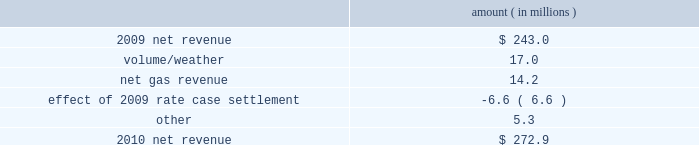Entergy new orleans , inc .
Management 2019s financial discussion and analysis the volume/weather variance is primarily due to an increase in electricity usage in the residential and commercial sectors due in part to a 4% ( 4 % ) increase in the average number of residential customers and a 3% ( 3 % ) increase in the average number of commercial customers , partially offset by the effect of less favorable weather on residential sales .
Gross operating revenues gross operating revenues decreased primarily due to : a decrease of $ 16.2 million in electric fuel cost recovery revenues due to lower fuel rates ; a decrease of $ 15.4 million in gross gas revenues primarily due to lower fuel cost recovery revenues as a result of lower fuel rates and the effect of milder weather ; and formula rate plan decreases effective october 2010 and october 2011 , as discussed above .
The decrease was partially offset by an increase in gross wholesale revenue due to increased sales to affiliated customers and more favorable volume/weather , as discussed above .
2010 compared to 2009 net revenue consists of operating revenues net of : 1 ) fuel , fuel-related expenses , and gas purchased for resale , 2 ) purchased power expenses , and 3 ) other regulatory charges ( credits ) .
Following is an analysis of the change in net revenue comparing 2010 to 2009 .
Amount ( in millions ) .
The volume/weather variance is primarily due to an increase of 348 gwh , or 7% ( 7 % ) , in billed retail electricity usage primarily due to more favorable weather compared to last year .
The net gas revenue variance is primarily due to more favorable weather compared to last year , along with the recognition of a gas regulatory asset associated with the settlement of entergy new orleans 2019s electric and gas formula rate plans .
See note 2 to the financial statements for further discussion of the formula rate plan settlement .
The effect of 2009 rate case settlement variance results from the april 2009 settlement of entergy new orleans 2019s rate case , and includes the effects of realigning non-fuel costs associated with the operation of grand gulf from the fuel adjustment clause to electric base rates effective june 2009 .
See note 2 to the financial statements for further discussion of the rate case settlement .
Other income statement variances 2011 compared to 2010 other operation and maintenance expenses decreased primarily due to the deferral in 2011 of $ 13.4 million of 2010 michoud plant maintenance costs pursuant to the settlement of entergy new orleans 2019s 2010 test year formula rate plan filing approved by the city council in september 2011 and a decrease of $ 8.0 million in fossil- fueled generation expenses due to higher plant outage costs in 2010 due to a greater scope of work at the michoud plant .
See note 2 to the financial statements for more discussion of the 2010 test year formula rate plan filing. .
What is the growth rate in net revenue from 2009 to 2010? 
Computations: ((272.9 - 243.0) / 243.0)
Answer: 0.12305. 